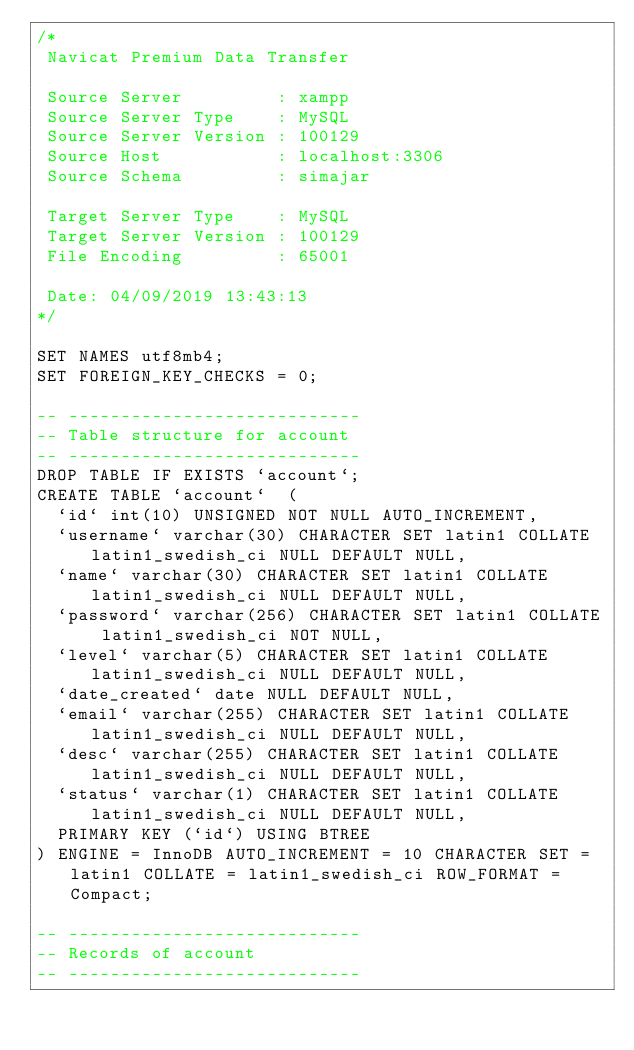<code> <loc_0><loc_0><loc_500><loc_500><_SQL_>/*
 Navicat Premium Data Transfer

 Source Server         : xampp
 Source Server Type    : MySQL
 Source Server Version : 100129
 Source Host           : localhost:3306
 Source Schema         : simajar

 Target Server Type    : MySQL
 Target Server Version : 100129
 File Encoding         : 65001

 Date: 04/09/2019 13:43:13
*/

SET NAMES utf8mb4;
SET FOREIGN_KEY_CHECKS = 0;

-- ----------------------------
-- Table structure for account
-- ----------------------------
DROP TABLE IF EXISTS `account`;
CREATE TABLE `account`  (
  `id` int(10) UNSIGNED NOT NULL AUTO_INCREMENT,
  `username` varchar(30) CHARACTER SET latin1 COLLATE latin1_swedish_ci NULL DEFAULT NULL,
  `name` varchar(30) CHARACTER SET latin1 COLLATE latin1_swedish_ci NULL DEFAULT NULL,
  `password` varchar(256) CHARACTER SET latin1 COLLATE latin1_swedish_ci NOT NULL,
  `level` varchar(5) CHARACTER SET latin1 COLLATE latin1_swedish_ci NULL DEFAULT NULL,
  `date_created` date NULL DEFAULT NULL,
  `email` varchar(255) CHARACTER SET latin1 COLLATE latin1_swedish_ci NULL DEFAULT NULL,
  `desc` varchar(255) CHARACTER SET latin1 COLLATE latin1_swedish_ci NULL DEFAULT NULL,
  `status` varchar(1) CHARACTER SET latin1 COLLATE latin1_swedish_ci NULL DEFAULT NULL,
  PRIMARY KEY (`id`) USING BTREE
) ENGINE = InnoDB AUTO_INCREMENT = 10 CHARACTER SET = latin1 COLLATE = latin1_swedish_ci ROW_FORMAT = Compact;

-- ----------------------------
-- Records of account
-- ----------------------------</code> 